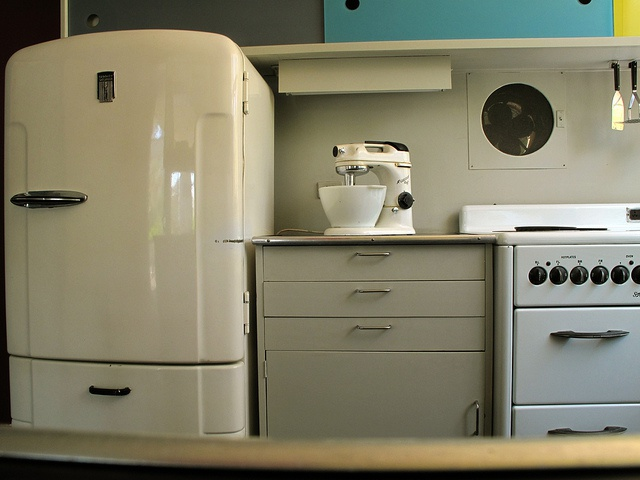Describe the objects in this image and their specific colors. I can see refrigerator in black, tan, and gray tones, oven in black, darkgray, lightgray, and gray tones, and bowl in black, darkgray, and lightgray tones in this image. 